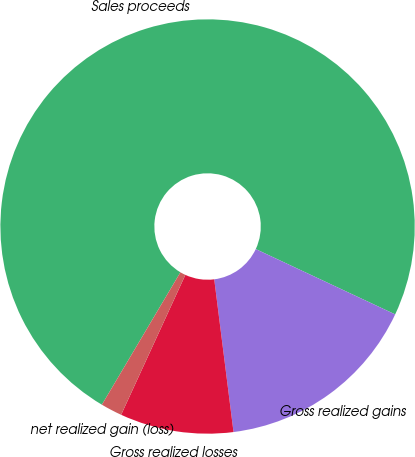Convert chart. <chart><loc_0><loc_0><loc_500><loc_500><pie_chart><fcel>Sales proceeds<fcel>Gross realized gains<fcel>Gross realized losses<fcel>net realized gain (loss)<nl><fcel>73.46%<fcel>16.03%<fcel>8.85%<fcel>1.67%<nl></chart> 